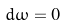Convert formula to latex. <formula><loc_0><loc_0><loc_500><loc_500>d \omega = 0</formula> 